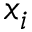<formula> <loc_0><loc_0><loc_500><loc_500>x _ { i }</formula> 